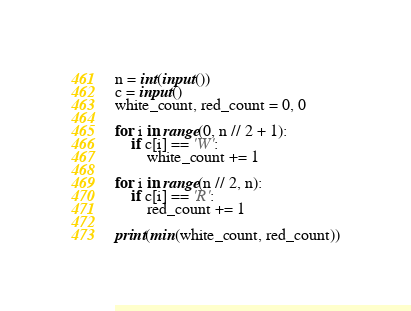Convert code to text. <code><loc_0><loc_0><loc_500><loc_500><_Python_>n = int(input())
c = input()
white_count, red_count = 0, 0

for i in range(0, n // 2 + 1):
    if c[i] == 'W':
        white_count += 1

for i in range(n // 2, n):
    if c[i] == 'R':
        red_count += 1

print(min(white_count, red_count))</code> 